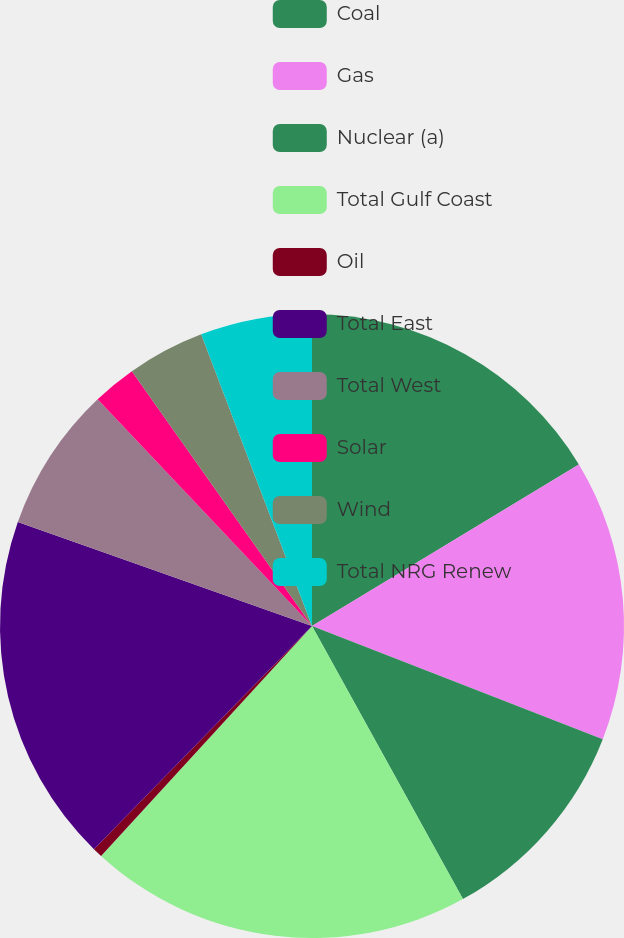<chart> <loc_0><loc_0><loc_500><loc_500><pie_chart><fcel>Coal<fcel>Gas<fcel>Nuclear (a)<fcel>Total Gulf Coast<fcel>Oil<fcel>Total East<fcel>Total West<fcel>Solar<fcel>Wind<fcel>Total NRG Renew<nl><fcel>16.34%<fcel>14.58%<fcel>11.06%<fcel>19.86%<fcel>0.5%<fcel>18.1%<fcel>7.54%<fcel>2.26%<fcel>4.02%<fcel>5.78%<nl></chart> 